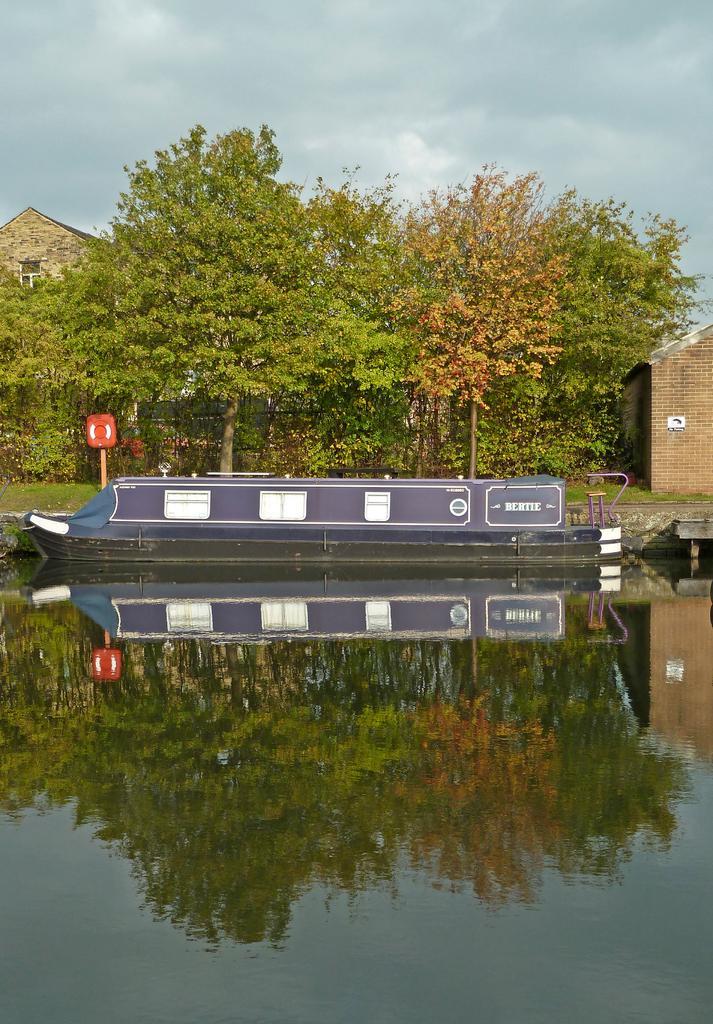How would you summarize this image in a sentence or two? In this image there are few trees, buildings, a board, an object attached to the wooden stick, water, there are some reflections of trees in the water and the sky. 